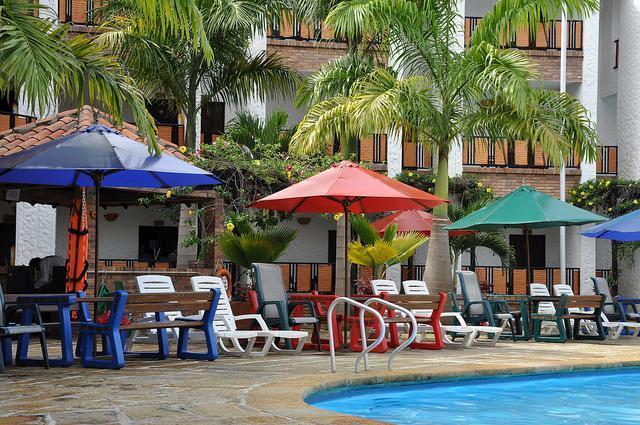How many benches can you see?
Give a very brief answer. 3. How many chairs are there?
Give a very brief answer. 4. How many umbrellas can you see?
Give a very brief answer. 3. 